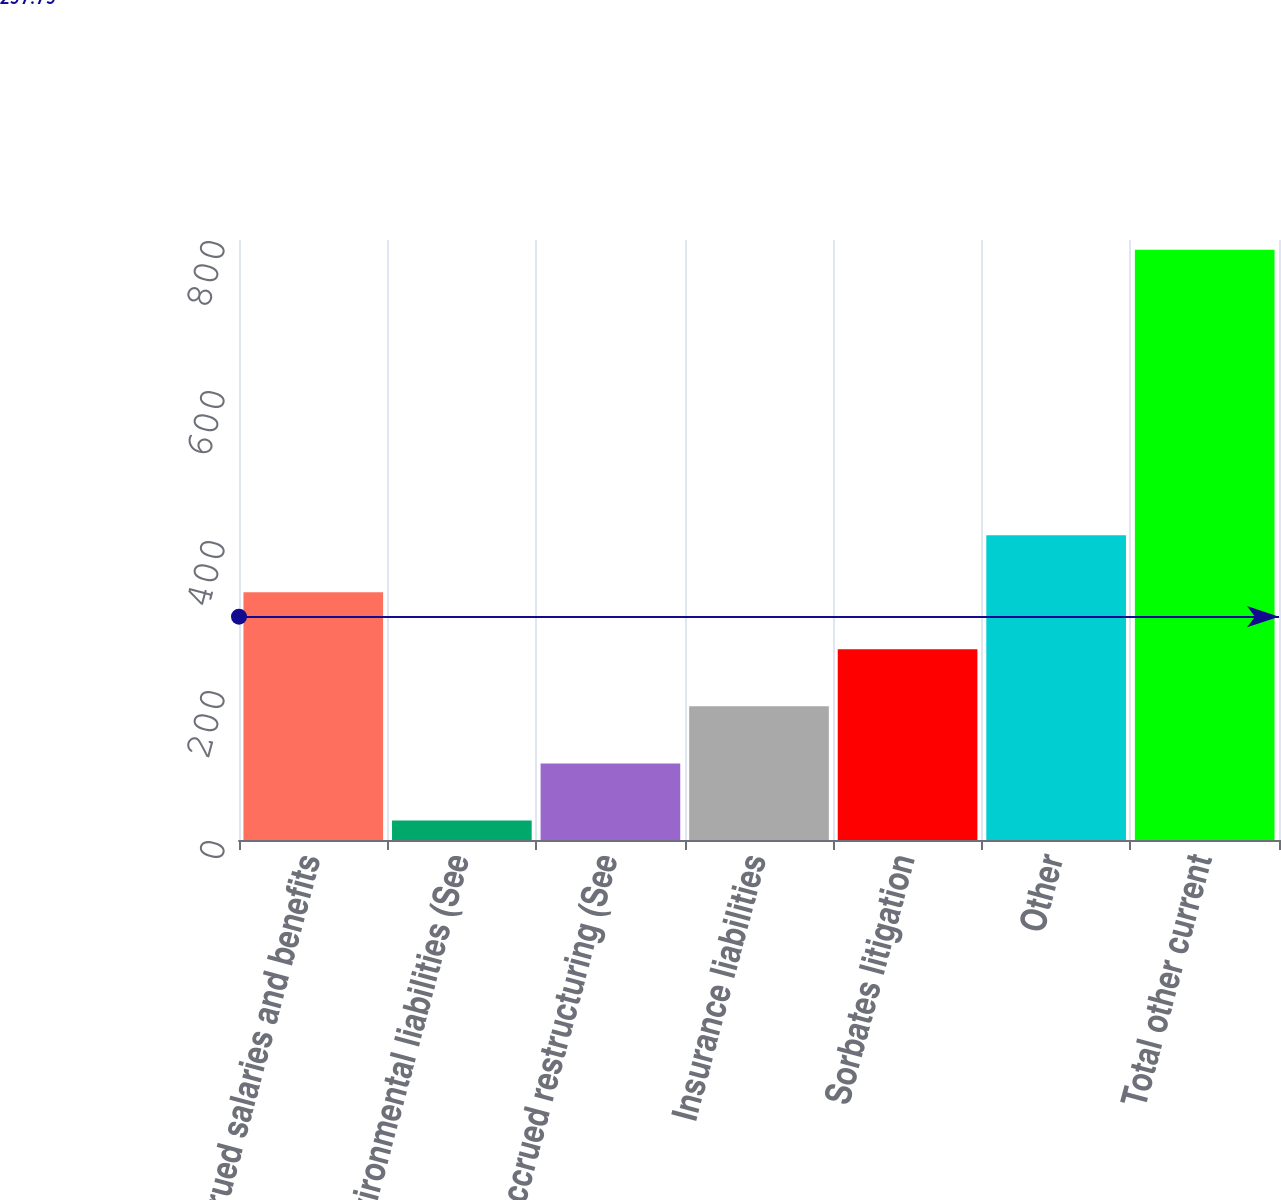Convert chart. <chart><loc_0><loc_0><loc_500><loc_500><bar_chart><fcel>Accrued salaries and benefits<fcel>Environmental liabilities (See<fcel>Accrued restructuring (See<fcel>Insurance liabilities<fcel>Sorbates litigation<fcel>Other<fcel>Total other current<nl><fcel>330.4<fcel>26<fcel>102.1<fcel>178.2<fcel>254.3<fcel>406.5<fcel>787<nl></chart> 